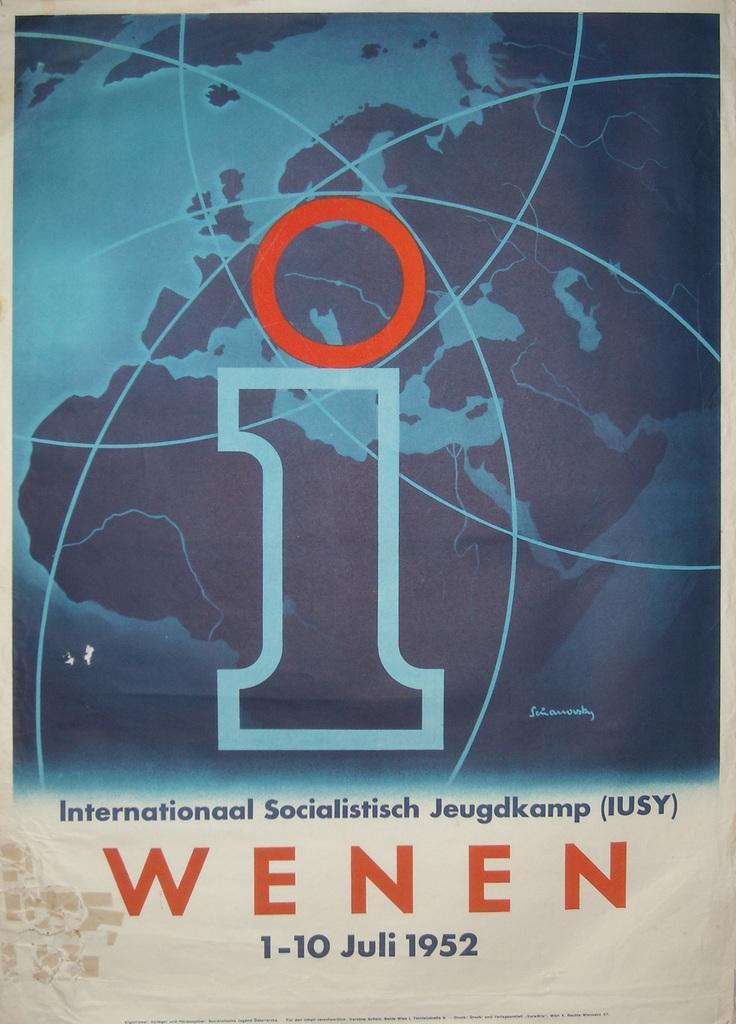Please provide a concise description of this image. In this image we can see a poster with map and some text on it. 